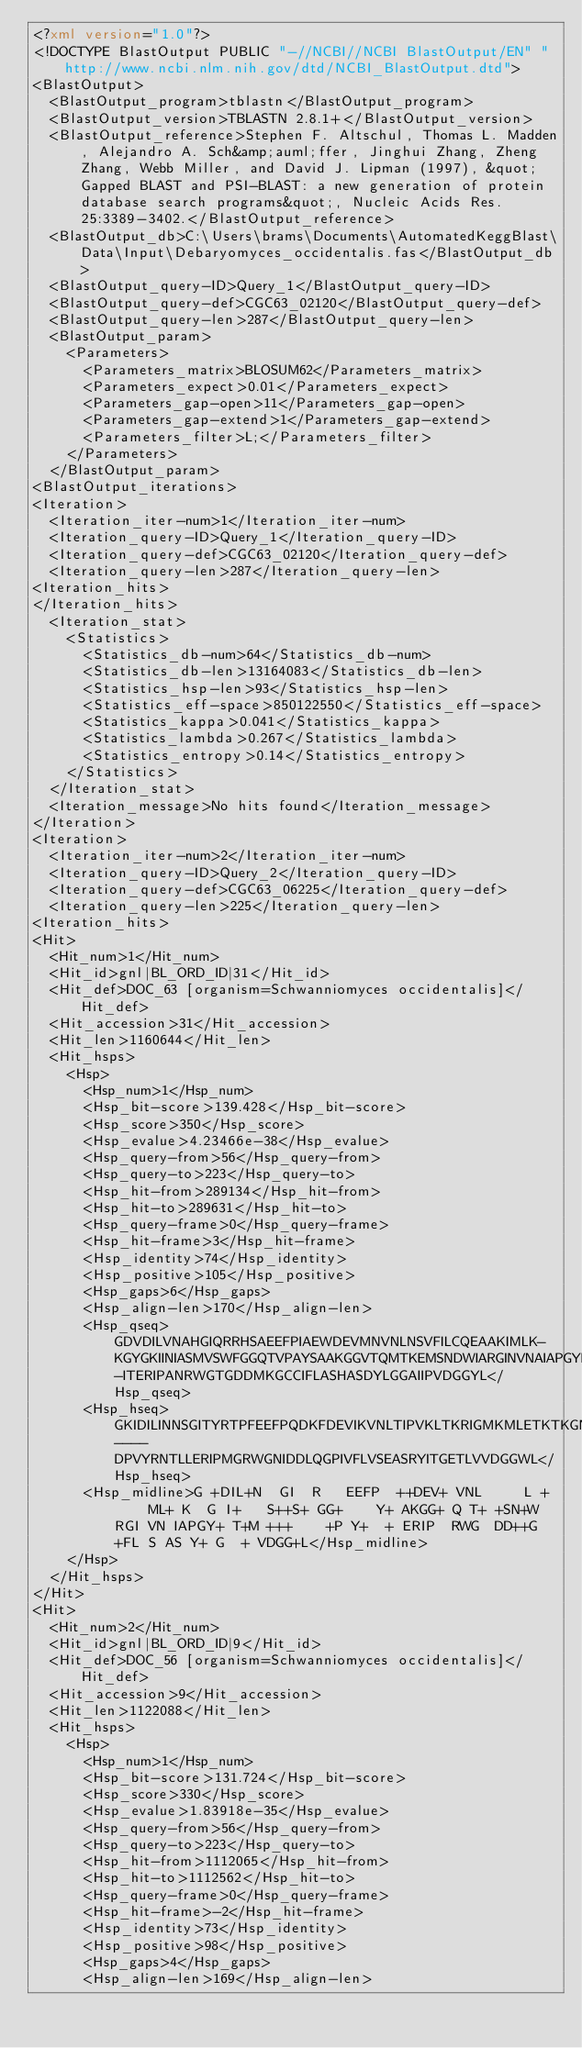Convert code to text. <code><loc_0><loc_0><loc_500><loc_500><_XML_><?xml version="1.0"?>
<!DOCTYPE BlastOutput PUBLIC "-//NCBI//NCBI BlastOutput/EN" "http://www.ncbi.nlm.nih.gov/dtd/NCBI_BlastOutput.dtd">
<BlastOutput>
  <BlastOutput_program>tblastn</BlastOutput_program>
  <BlastOutput_version>TBLASTN 2.8.1+</BlastOutput_version>
  <BlastOutput_reference>Stephen F. Altschul, Thomas L. Madden, Alejandro A. Sch&amp;auml;ffer, Jinghui Zhang, Zheng Zhang, Webb Miller, and David J. Lipman (1997), &quot;Gapped BLAST and PSI-BLAST: a new generation of protein database search programs&quot;, Nucleic Acids Res. 25:3389-3402.</BlastOutput_reference>
  <BlastOutput_db>C:\Users\brams\Documents\AutomatedKeggBlast\Data\Input\Debaryomyces_occidentalis.fas</BlastOutput_db>
  <BlastOutput_query-ID>Query_1</BlastOutput_query-ID>
  <BlastOutput_query-def>CGC63_02120</BlastOutput_query-def>
  <BlastOutput_query-len>287</BlastOutput_query-len>
  <BlastOutput_param>
    <Parameters>
      <Parameters_matrix>BLOSUM62</Parameters_matrix>
      <Parameters_expect>0.01</Parameters_expect>
      <Parameters_gap-open>11</Parameters_gap-open>
      <Parameters_gap-extend>1</Parameters_gap-extend>
      <Parameters_filter>L;</Parameters_filter>
    </Parameters>
  </BlastOutput_param>
<BlastOutput_iterations>
<Iteration>
  <Iteration_iter-num>1</Iteration_iter-num>
  <Iteration_query-ID>Query_1</Iteration_query-ID>
  <Iteration_query-def>CGC63_02120</Iteration_query-def>
  <Iteration_query-len>287</Iteration_query-len>
<Iteration_hits>
</Iteration_hits>
  <Iteration_stat>
    <Statistics>
      <Statistics_db-num>64</Statistics_db-num>
      <Statistics_db-len>13164083</Statistics_db-len>
      <Statistics_hsp-len>93</Statistics_hsp-len>
      <Statistics_eff-space>850122550</Statistics_eff-space>
      <Statistics_kappa>0.041</Statistics_kappa>
      <Statistics_lambda>0.267</Statistics_lambda>
      <Statistics_entropy>0.14</Statistics_entropy>
    </Statistics>
  </Iteration_stat>
  <Iteration_message>No hits found</Iteration_message>
</Iteration>
<Iteration>
  <Iteration_iter-num>2</Iteration_iter-num>
  <Iteration_query-ID>Query_2</Iteration_query-ID>
  <Iteration_query-def>CGC63_06225</Iteration_query-def>
  <Iteration_query-len>225</Iteration_query-len>
<Iteration_hits>
<Hit>
  <Hit_num>1</Hit_num>
  <Hit_id>gnl|BL_ORD_ID|31</Hit_id>
  <Hit_def>DOC_63 [organism=Schwanniomyces occidentalis]</Hit_def>
  <Hit_accession>31</Hit_accession>
  <Hit_len>1160644</Hit_len>
  <Hit_hsps>
    <Hsp>
      <Hsp_num>1</Hsp_num>
      <Hsp_bit-score>139.428</Hsp_bit-score>
      <Hsp_score>350</Hsp_score>
      <Hsp_evalue>4.23466e-38</Hsp_evalue>
      <Hsp_query-from>56</Hsp_query-from>
      <Hsp_query-to>223</Hsp_query-to>
      <Hsp_hit-from>289134</Hsp_hit-from>
      <Hsp_hit-to>289631</Hsp_hit-to>
      <Hsp_query-frame>0</Hsp_query-frame>
      <Hsp_hit-frame>3</Hsp_hit-frame>
      <Hsp_identity>74</Hsp_identity>
      <Hsp_positive>105</Hsp_positive>
      <Hsp_gaps>6</Hsp_gaps>
      <Hsp_align-len>170</Hsp_align-len>
      <Hsp_qseq>GDVDILVNAHGIQRRHSAEEFPIAEWDEVMNVNLNSVFILCQEAAKIMLK-KGYGKIINIASMVSWFGGQTVPAYSAAKGGVTQMTKEMSNDWIARGINVNAIAPGYMATKMNEALLDEKNPRYQQ-ITERIPANRWGTGDDMKGCCIFLASHASDYLGGAIIPVDGGYL</Hsp_qseq>
      <Hsp_hseq>GKIDILINNSGITYRTPFEEFPQDKFDEVIKVNLTIPVKLTKRIGMKMLETKTKGNIVFTGSLLSFQGGEHSIPYAIAKGGIKQFTQALSNEWSYRGIRVNCIAPGYIKTEMTDSM----DPVYRNTLLERIPMGRWGNIDDLQGPIVFLVSEASRYITGETLVVDGGWL</Hsp_hseq>
      <Hsp_midline>G +DIL+N  GI  R   EEFP  ++DEV+ VNL     L +     ML+ K  G I+   S++S+ GG+    Y+ AKGG+ Q T+ +SN+W  RGI VN IAPGY+ T+M +++    +P Y+  + ERIP  RWG  DD++G  +FL S AS Y+ G  + VDGG+L</Hsp_midline>
    </Hsp>
  </Hit_hsps>
</Hit>
<Hit>
  <Hit_num>2</Hit_num>
  <Hit_id>gnl|BL_ORD_ID|9</Hit_id>
  <Hit_def>DOC_56 [organism=Schwanniomyces occidentalis]</Hit_def>
  <Hit_accession>9</Hit_accession>
  <Hit_len>1122088</Hit_len>
  <Hit_hsps>
    <Hsp>
      <Hsp_num>1</Hsp_num>
      <Hsp_bit-score>131.724</Hsp_bit-score>
      <Hsp_score>330</Hsp_score>
      <Hsp_evalue>1.83918e-35</Hsp_evalue>
      <Hsp_query-from>56</Hsp_query-from>
      <Hsp_query-to>223</Hsp_query-to>
      <Hsp_hit-from>1112065</Hsp_hit-from>
      <Hsp_hit-to>1112562</Hsp_hit-to>
      <Hsp_query-frame>0</Hsp_query-frame>
      <Hsp_hit-frame>-2</Hsp_hit-frame>
      <Hsp_identity>73</Hsp_identity>
      <Hsp_positive>98</Hsp_positive>
      <Hsp_gaps>4</Hsp_gaps>
      <Hsp_align-len>169</Hsp_align-len></code> 